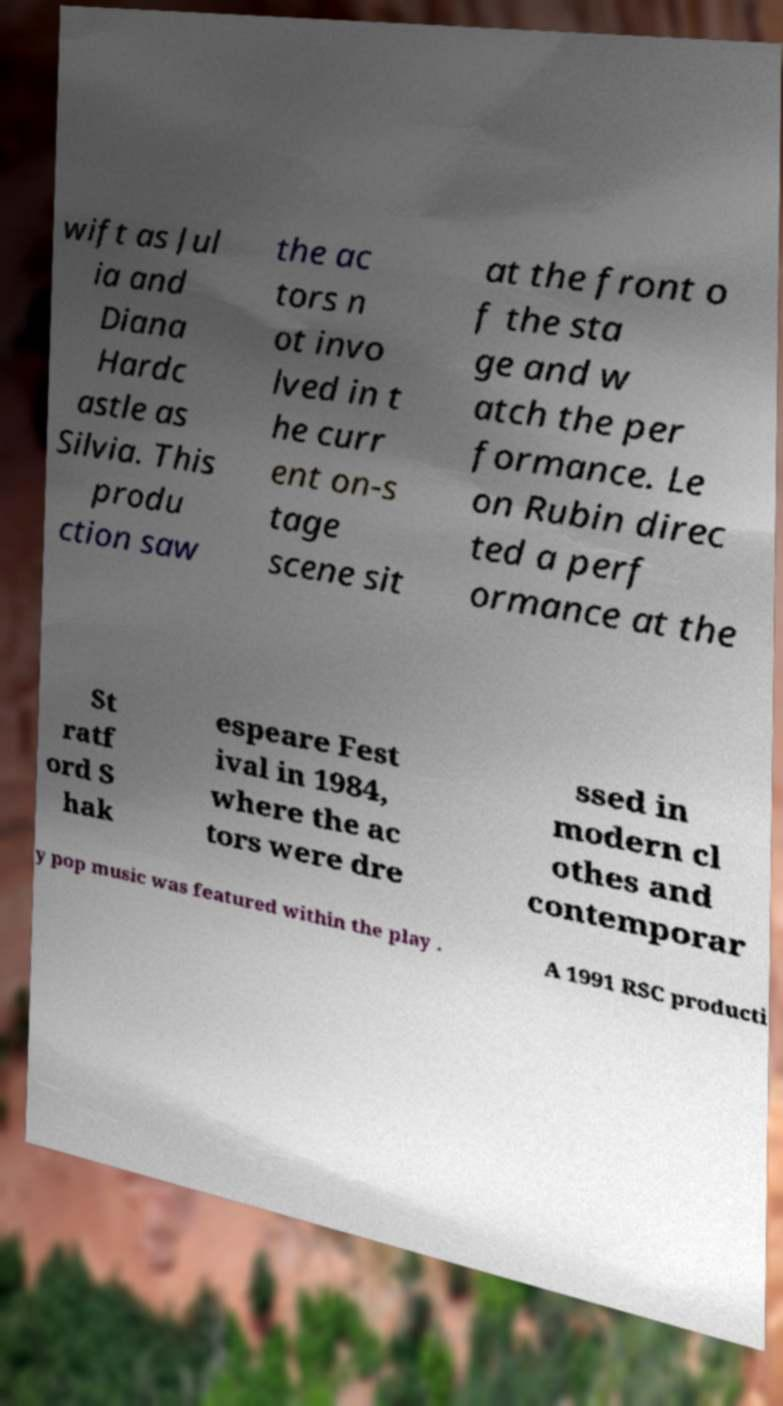Can you accurately transcribe the text from the provided image for me? wift as Jul ia and Diana Hardc astle as Silvia. This produ ction saw the ac tors n ot invo lved in t he curr ent on-s tage scene sit at the front o f the sta ge and w atch the per formance. Le on Rubin direc ted a perf ormance at the St ratf ord S hak espeare Fest ival in 1984, where the ac tors were dre ssed in modern cl othes and contemporar y pop music was featured within the play . A 1991 RSC producti 